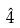<formula> <loc_0><loc_0><loc_500><loc_500>\hat { 4 }</formula> 